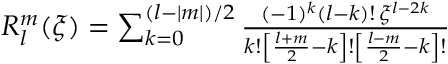Convert formula to latex. <formula><loc_0><loc_0><loc_500><loc_500>\begin{array} { r } { R _ { l } ^ { m } ( \xi ) = \sum _ { k = 0 } ^ { ( l - | m | ) / 2 } \frac { ( - 1 ) ^ { k } ( l - k ) ! \, \xi ^ { l - 2 k } } { k ! \left [ \frac { l + m } { 2 } - k \right ] ! \left [ \frac { l - m } { 2 } - k \right ] ! } } \end{array}</formula> 